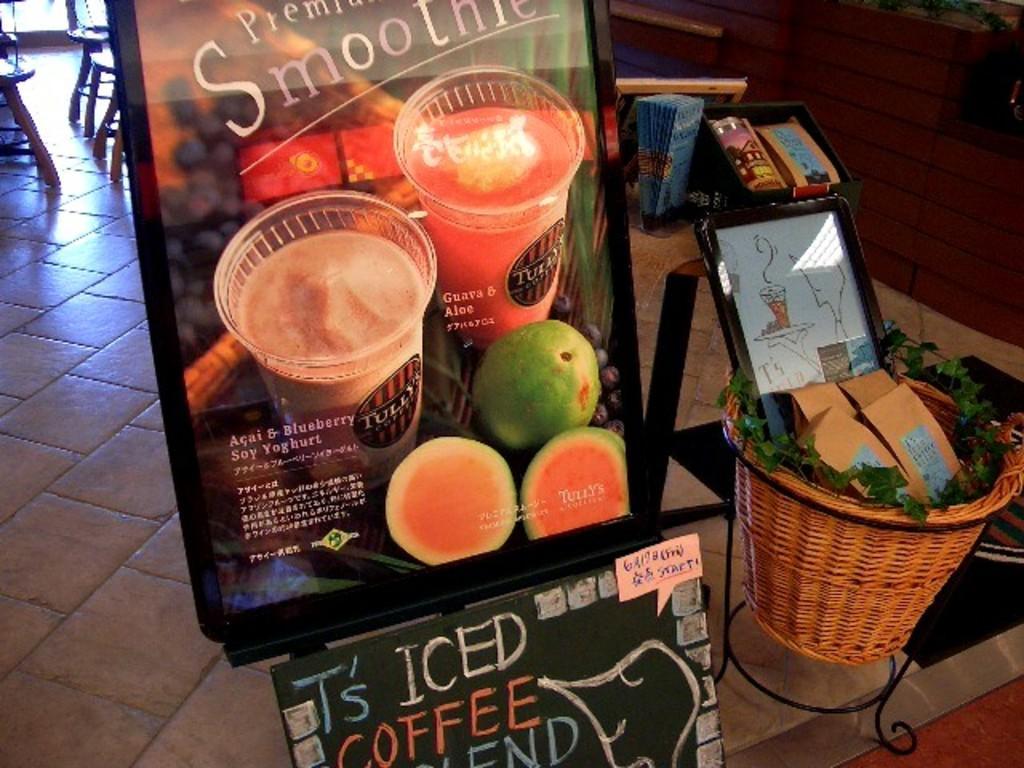Can you describe this image briefly? In this image we can see boards with text and pictures of fruits, glasses on it, there is a basket on the stand, in the basket there are plants, packets, photo frame, there are papers and boxes, also we can see chairs, and the wall. 